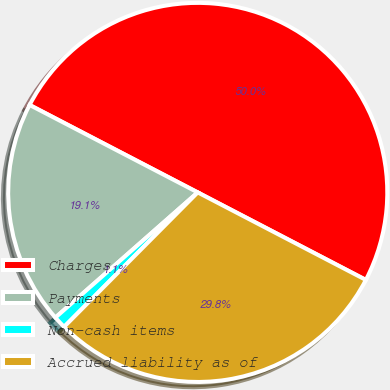<chart> <loc_0><loc_0><loc_500><loc_500><pie_chart><fcel>Charges<fcel>Payments<fcel>Non-cash items<fcel>Accrued liability as of<nl><fcel>50.0%<fcel>19.11%<fcel>1.07%<fcel>29.81%<nl></chart> 